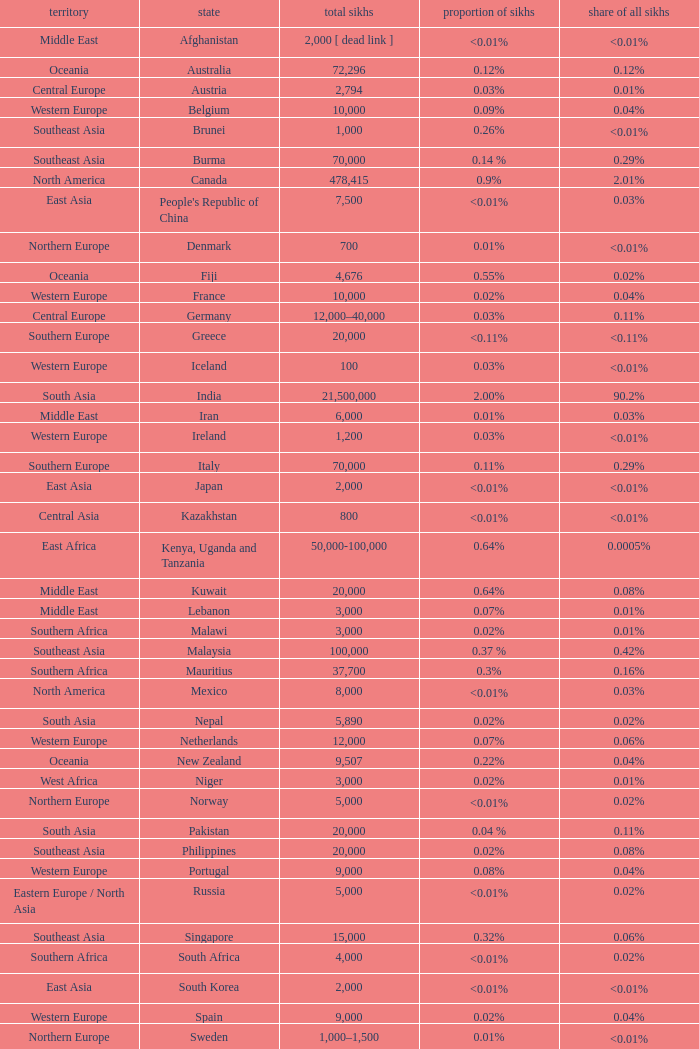What is the number of sikhs in Japan? 2000.0. 